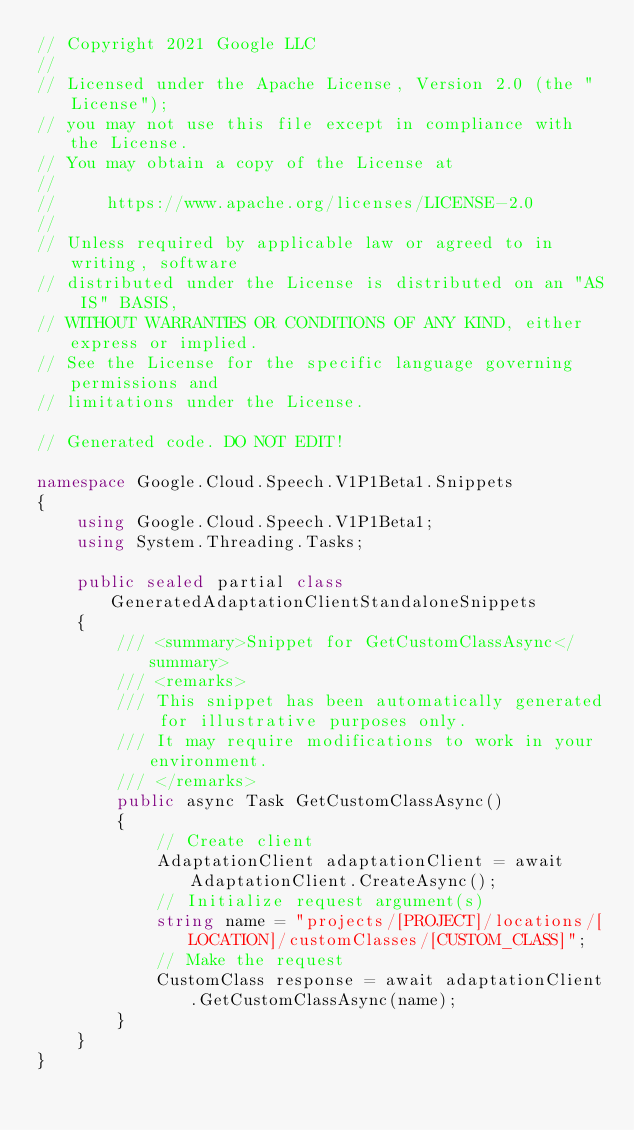Convert code to text. <code><loc_0><loc_0><loc_500><loc_500><_C#_>// Copyright 2021 Google LLC
//
// Licensed under the Apache License, Version 2.0 (the "License");
// you may not use this file except in compliance with the License.
// You may obtain a copy of the License at
//
//     https://www.apache.org/licenses/LICENSE-2.0
//
// Unless required by applicable law or agreed to in writing, software
// distributed under the License is distributed on an "AS IS" BASIS,
// WITHOUT WARRANTIES OR CONDITIONS OF ANY KIND, either express or implied.
// See the License for the specific language governing permissions and
// limitations under the License.

// Generated code. DO NOT EDIT!

namespace Google.Cloud.Speech.V1P1Beta1.Snippets
{
    using Google.Cloud.Speech.V1P1Beta1;
    using System.Threading.Tasks;

    public sealed partial class GeneratedAdaptationClientStandaloneSnippets
    {
        /// <summary>Snippet for GetCustomClassAsync</summary>
        /// <remarks>
        /// This snippet has been automatically generated for illustrative purposes only.
        /// It may require modifications to work in your environment.
        /// </remarks>
        public async Task GetCustomClassAsync()
        {
            // Create client
            AdaptationClient adaptationClient = await AdaptationClient.CreateAsync();
            // Initialize request argument(s)
            string name = "projects/[PROJECT]/locations/[LOCATION]/customClasses/[CUSTOM_CLASS]";
            // Make the request
            CustomClass response = await adaptationClient.GetCustomClassAsync(name);
        }
    }
}
</code> 